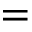<formula> <loc_0><loc_0><loc_500><loc_500>=</formula> 